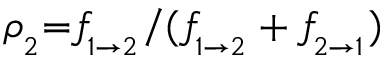Convert formula to latex. <formula><loc_0><loc_0><loc_500><loc_500>\rho _ { _ { 2 } } { = } f \, _ { _ { 1 { \rightarrow } 2 } } / ( f \, _ { _ { 1 { \rightarrow } 2 } } + f \, _ { _ { 2 { \rightarrow } 1 } } )</formula> 